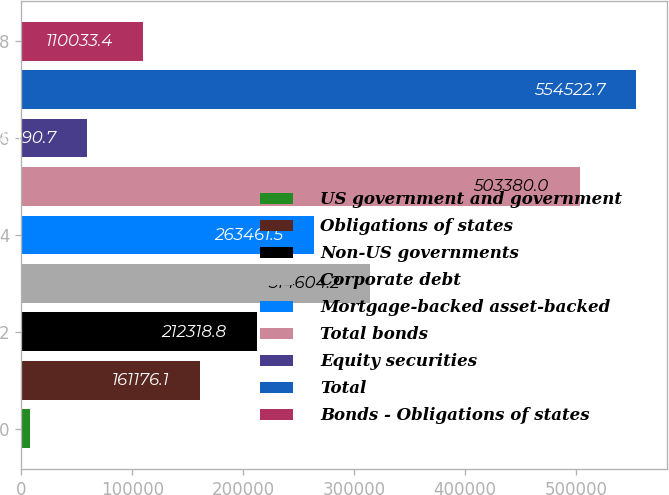<chart> <loc_0><loc_0><loc_500><loc_500><bar_chart><fcel>US government and government<fcel>Obligations of states<fcel>Non-US governments<fcel>Corporate debt<fcel>Mortgage-backed asset-backed<fcel>Total bonds<fcel>Equity securities<fcel>Total<fcel>Bonds - Obligations of states<nl><fcel>7748<fcel>161176<fcel>212319<fcel>314604<fcel>263462<fcel>503380<fcel>58890.7<fcel>554523<fcel>110033<nl></chart> 